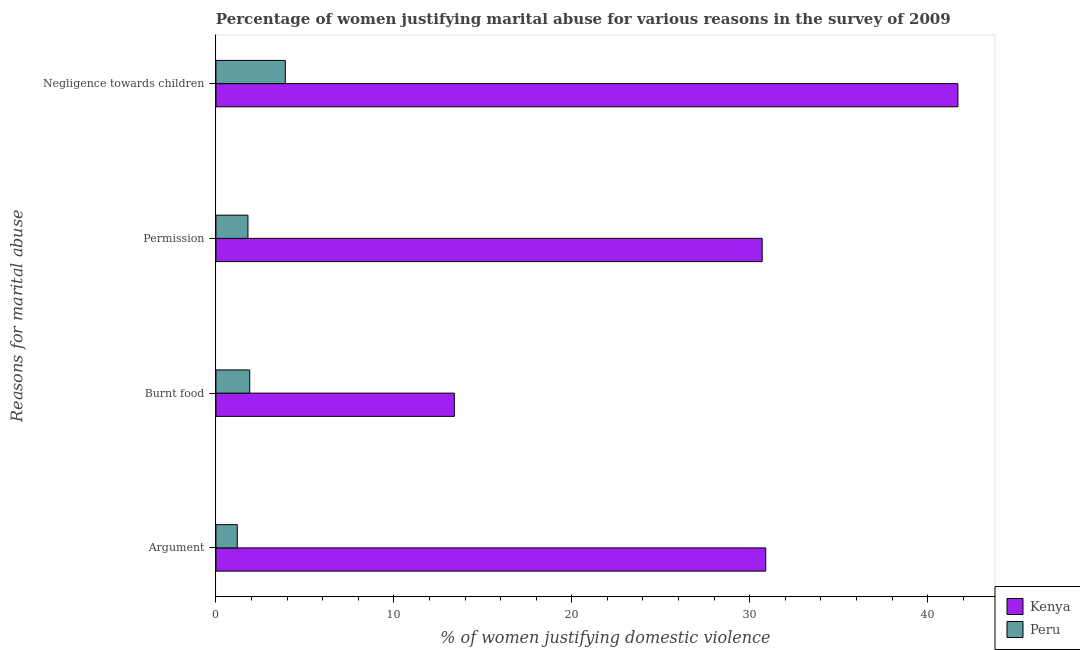How many different coloured bars are there?
Your response must be concise. 2. Are the number of bars on each tick of the Y-axis equal?
Give a very brief answer. Yes. How many bars are there on the 2nd tick from the top?
Ensure brevity in your answer.  2. How many bars are there on the 4th tick from the bottom?
Your answer should be very brief. 2. What is the label of the 4th group of bars from the top?
Your answer should be compact. Argument. What is the percentage of women justifying abuse in the case of an argument in Peru?
Your answer should be compact. 1.2. Across all countries, what is the maximum percentage of women justifying abuse for burning food?
Give a very brief answer. 13.4. In which country was the percentage of women justifying abuse for showing negligence towards children maximum?
Your response must be concise. Kenya. In which country was the percentage of women justifying abuse for burning food minimum?
Your response must be concise. Peru. What is the total percentage of women justifying abuse for burning food in the graph?
Provide a short and direct response. 15.3. What is the difference between the percentage of women justifying abuse for showing negligence towards children in Kenya and that in Peru?
Make the answer very short. 37.8. What is the difference between the percentage of women justifying abuse in the case of an argument in Peru and the percentage of women justifying abuse for showing negligence towards children in Kenya?
Ensure brevity in your answer.  -40.5. What is the average percentage of women justifying abuse in the case of an argument per country?
Offer a terse response. 16.05. What is the difference between the percentage of women justifying abuse for going without permission and percentage of women justifying abuse for showing negligence towards children in Peru?
Make the answer very short. -2.1. In how many countries, is the percentage of women justifying abuse in the case of an argument greater than 14 %?
Your answer should be very brief. 1. What is the ratio of the percentage of women justifying abuse for going without permission in Kenya to that in Peru?
Offer a very short reply. 17.06. What is the difference between the highest and the lowest percentage of women justifying abuse for showing negligence towards children?
Your answer should be very brief. 37.8. In how many countries, is the percentage of women justifying abuse for showing negligence towards children greater than the average percentage of women justifying abuse for showing negligence towards children taken over all countries?
Offer a terse response. 1. Is it the case that in every country, the sum of the percentage of women justifying abuse for burning food and percentage of women justifying abuse for showing negligence towards children is greater than the sum of percentage of women justifying abuse in the case of an argument and percentage of women justifying abuse for going without permission?
Provide a short and direct response. No. What does the 2nd bar from the top in Burnt food represents?
Offer a very short reply. Kenya. What does the 2nd bar from the bottom in Burnt food represents?
Ensure brevity in your answer.  Peru. How many bars are there?
Ensure brevity in your answer.  8. Are all the bars in the graph horizontal?
Make the answer very short. Yes. What is the difference between two consecutive major ticks on the X-axis?
Your answer should be very brief. 10. Are the values on the major ticks of X-axis written in scientific E-notation?
Keep it short and to the point. No. Where does the legend appear in the graph?
Ensure brevity in your answer.  Bottom right. What is the title of the graph?
Offer a very short reply. Percentage of women justifying marital abuse for various reasons in the survey of 2009. What is the label or title of the X-axis?
Your answer should be very brief. % of women justifying domestic violence. What is the label or title of the Y-axis?
Provide a short and direct response. Reasons for marital abuse. What is the % of women justifying domestic violence in Kenya in Argument?
Offer a very short reply. 30.9. What is the % of women justifying domestic violence of Peru in Burnt food?
Ensure brevity in your answer.  1.9. What is the % of women justifying domestic violence of Kenya in Permission?
Offer a very short reply. 30.7. What is the % of women justifying domestic violence in Peru in Permission?
Make the answer very short. 1.8. What is the % of women justifying domestic violence of Kenya in Negligence towards children?
Give a very brief answer. 41.7. What is the % of women justifying domestic violence in Peru in Negligence towards children?
Offer a very short reply. 3.9. Across all Reasons for marital abuse, what is the maximum % of women justifying domestic violence of Kenya?
Offer a terse response. 41.7. What is the total % of women justifying domestic violence of Kenya in the graph?
Give a very brief answer. 116.7. What is the total % of women justifying domestic violence in Peru in the graph?
Offer a very short reply. 8.8. What is the difference between the % of women justifying domestic violence of Kenya in Argument and that in Burnt food?
Provide a succinct answer. 17.5. What is the difference between the % of women justifying domestic violence in Kenya in Argument and that in Permission?
Provide a short and direct response. 0.2. What is the difference between the % of women justifying domestic violence of Kenya in Argument and that in Negligence towards children?
Provide a short and direct response. -10.8. What is the difference between the % of women justifying domestic violence in Kenya in Burnt food and that in Permission?
Offer a very short reply. -17.3. What is the difference between the % of women justifying domestic violence in Peru in Burnt food and that in Permission?
Offer a terse response. 0.1. What is the difference between the % of women justifying domestic violence in Kenya in Burnt food and that in Negligence towards children?
Keep it short and to the point. -28.3. What is the difference between the % of women justifying domestic violence in Kenya in Argument and the % of women justifying domestic violence in Peru in Permission?
Offer a terse response. 29.1. What is the difference between the % of women justifying domestic violence of Kenya in Argument and the % of women justifying domestic violence of Peru in Negligence towards children?
Provide a short and direct response. 27. What is the difference between the % of women justifying domestic violence in Kenya in Burnt food and the % of women justifying domestic violence in Peru in Permission?
Your response must be concise. 11.6. What is the difference between the % of women justifying domestic violence in Kenya in Permission and the % of women justifying domestic violence in Peru in Negligence towards children?
Offer a very short reply. 26.8. What is the average % of women justifying domestic violence of Kenya per Reasons for marital abuse?
Provide a short and direct response. 29.18. What is the average % of women justifying domestic violence in Peru per Reasons for marital abuse?
Your response must be concise. 2.2. What is the difference between the % of women justifying domestic violence in Kenya and % of women justifying domestic violence in Peru in Argument?
Provide a short and direct response. 29.7. What is the difference between the % of women justifying domestic violence in Kenya and % of women justifying domestic violence in Peru in Burnt food?
Offer a terse response. 11.5. What is the difference between the % of women justifying domestic violence of Kenya and % of women justifying domestic violence of Peru in Permission?
Your response must be concise. 28.9. What is the difference between the % of women justifying domestic violence of Kenya and % of women justifying domestic violence of Peru in Negligence towards children?
Your answer should be very brief. 37.8. What is the ratio of the % of women justifying domestic violence in Kenya in Argument to that in Burnt food?
Offer a terse response. 2.31. What is the ratio of the % of women justifying domestic violence of Peru in Argument to that in Burnt food?
Ensure brevity in your answer.  0.63. What is the ratio of the % of women justifying domestic violence of Kenya in Argument to that in Negligence towards children?
Give a very brief answer. 0.74. What is the ratio of the % of women justifying domestic violence of Peru in Argument to that in Negligence towards children?
Ensure brevity in your answer.  0.31. What is the ratio of the % of women justifying domestic violence in Kenya in Burnt food to that in Permission?
Keep it short and to the point. 0.44. What is the ratio of the % of women justifying domestic violence in Peru in Burnt food to that in Permission?
Make the answer very short. 1.06. What is the ratio of the % of women justifying domestic violence of Kenya in Burnt food to that in Negligence towards children?
Your answer should be very brief. 0.32. What is the ratio of the % of women justifying domestic violence of Peru in Burnt food to that in Negligence towards children?
Your response must be concise. 0.49. What is the ratio of the % of women justifying domestic violence of Kenya in Permission to that in Negligence towards children?
Offer a very short reply. 0.74. What is the ratio of the % of women justifying domestic violence in Peru in Permission to that in Negligence towards children?
Ensure brevity in your answer.  0.46. What is the difference between the highest and the second highest % of women justifying domestic violence of Peru?
Offer a terse response. 2. What is the difference between the highest and the lowest % of women justifying domestic violence in Kenya?
Keep it short and to the point. 28.3. 